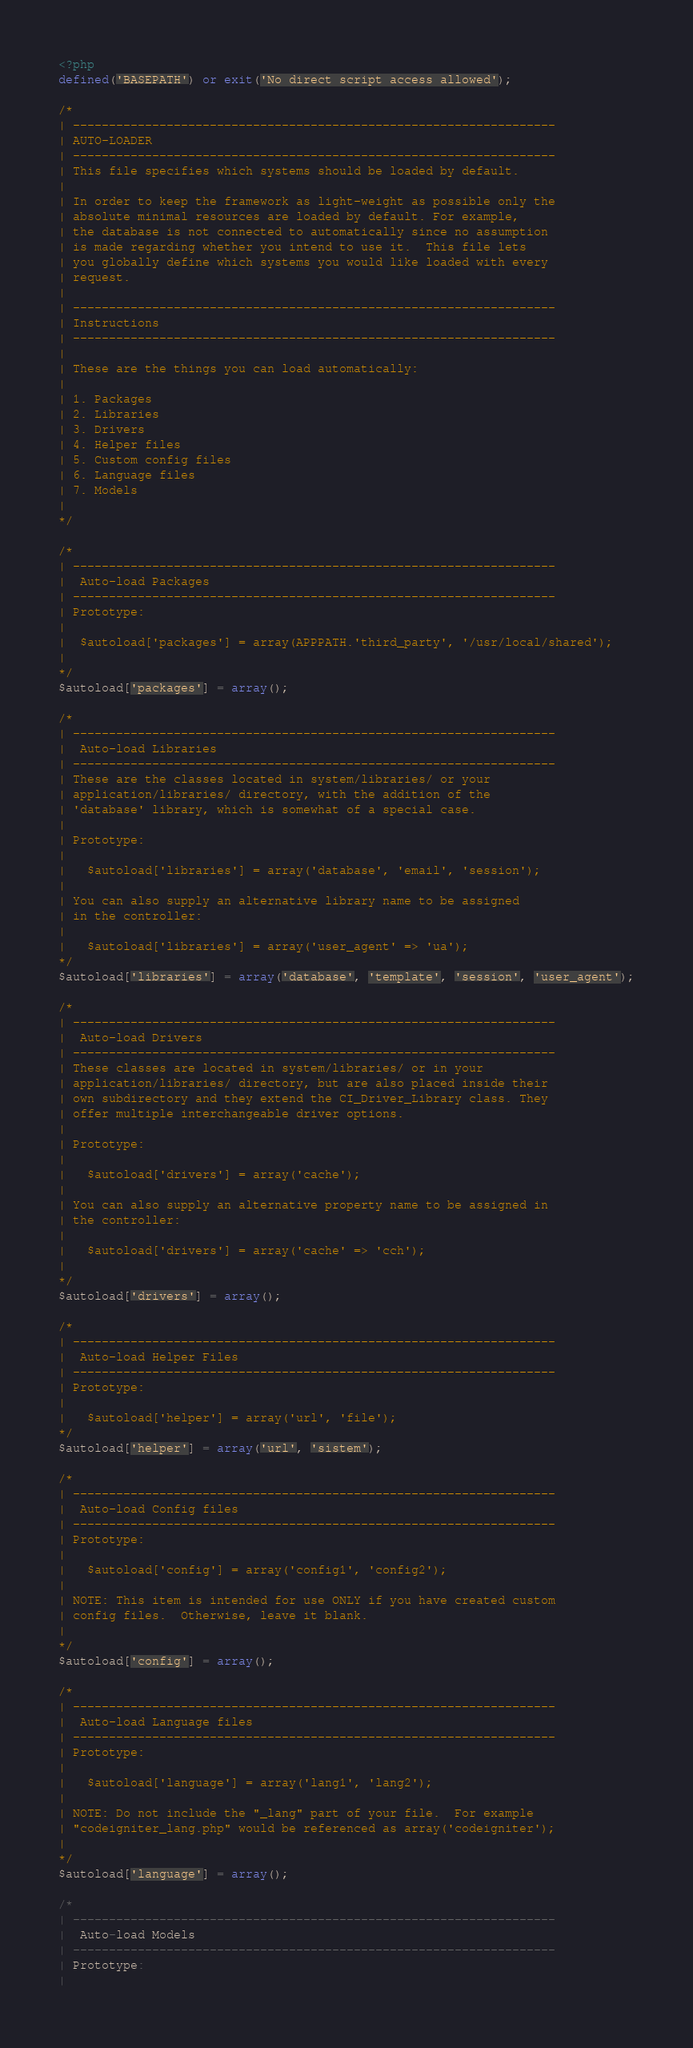Convert code to text. <code><loc_0><loc_0><loc_500><loc_500><_PHP_><?php
defined('BASEPATH') or exit('No direct script access allowed');

/*
| -------------------------------------------------------------------
| AUTO-LOADER
| -------------------------------------------------------------------
| This file specifies which systems should be loaded by default.
|
| In order to keep the framework as light-weight as possible only the
| absolute minimal resources are loaded by default. For example,
| the database is not connected to automatically since no assumption
| is made regarding whether you intend to use it.  This file lets
| you globally define which systems you would like loaded with every
| request.
|
| -------------------------------------------------------------------
| Instructions
| -------------------------------------------------------------------
|
| These are the things you can load automatically:
|
| 1. Packages
| 2. Libraries
| 3. Drivers
| 4. Helper files
| 5. Custom config files
| 6. Language files
| 7. Models
|
*/

/*
| -------------------------------------------------------------------
|  Auto-load Packages
| -------------------------------------------------------------------
| Prototype:
|
|  $autoload['packages'] = array(APPPATH.'third_party', '/usr/local/shared');
|
*/
$autoload['packages'] = array();

/*
| -------------------------------------------------------------------
|  Auto-load Libraries
| -------------------------------------------------------------------
| These are the classes located in system/libraries/ or your
| application/libraries/ directory, with the addition of the
| 'database' library, which is somewhat of a special case.
|
| Prototype:
|
|	$autoload['libraries'] = array('database', 'email', 'session');
|
| You can also supply an alternative library name to be assigned
| in the controller:
|
|	$autoload['libraries'] = array('user_agent' => 'ua');
*/
$autoload['libraries'] = array('database', 'template', 'session', 'user_agent');

/*
| -------------------------------------------------------------------
|  Auto-load Drivers
| -------------------------------------------------------------------
| These classes are located in system/libraries/ or in your
| application/libraries/ directory, but are also placed inside their
| own subdirectory and they extend the CI_Driver_Library class. They
| offer multiple interchangeable driver options.
|
| Prototype:
|
|	$autoload['drivers'] = array('cache');
|
| You can also supply an alternative property name to be assigned in
| the controller:
|
|	$autoload['drivers'] = array('cache' => 'cch');
|
*/
$autoload['drivers'] = array();

/*
| -------------------------------------------------------------------
|  Auto-load Helper Files
| -------------------------------------------------------------------
| Prototype:
|
|	$autoload['helper'] = array('url', 'file');
*/
$autoload['helper'] = array('url', 'sistem');

/*
| -------------------------------------------------------------------
|  Auto-load Config files
| -------------------------------------------------------------------
| Prototype:
|
|	$autoload['config'] = array('config1', 'config2');
|
| NOTE: This item is intended for use ONLY if you have created custom
| config files.  Otherwise, leave it blank.
|
*/
$autoload['config'] = array();

/*
| -------------------------------------------------------------------
|  Auto-load Language files
| -------------------------------------------------------------------
| Prototype:
|
|	$autoload['language'] = array('lang1', 'lang2');
|
| NOTE: Do not include the "_lang" part of your file.  For example
| "codeigniter_lang.php" would be referenced as array('codeigniter');
|
*/
$autoload['language'] = array();

/*
| -------------------------------------------------------------------
|  Auto-load Models
| -------------------------------------------------------------------
| Prototype:
|</code> 